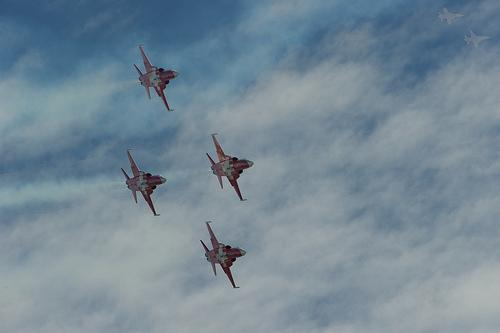Give a short overview of the image, focusing on the planes and their actions. Four jets are flying in a partly cloudy sky, positioned at various angles, with some reflections visible in the sky. In a few words, describe the weather condition depicted in this image. The sky is full of white and blue clouds, indicating a partly cloudy day. 